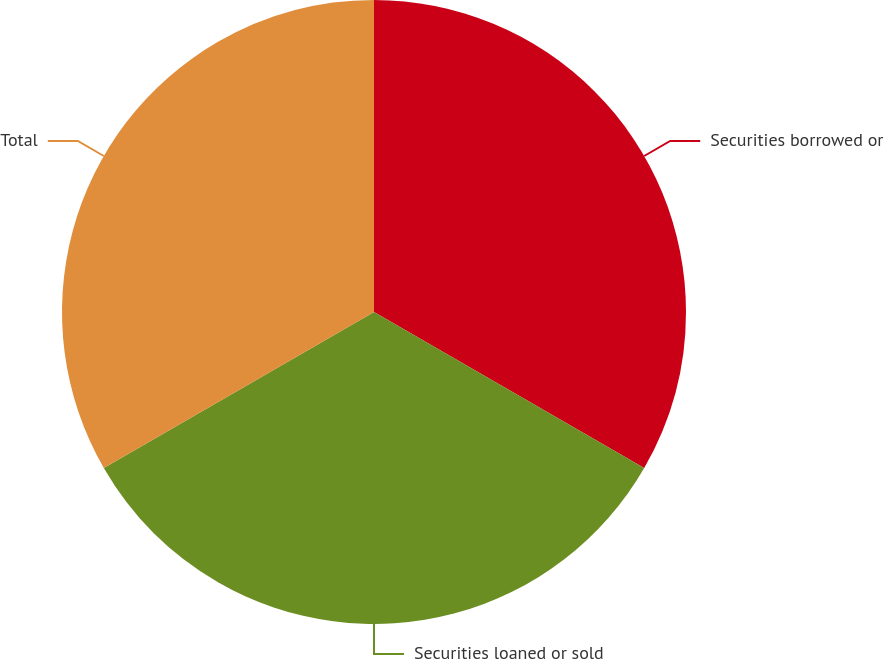Convert chart. <chart><loc_0><loc_0><loc_500><loc_500><pie_chart><fcel>Securities borrowed or<fcel>Securities loaned or sold<fcel>Total<nl><fcel>33.33%<fcel>33.33%<fcel>33.33%<nl></chart> 